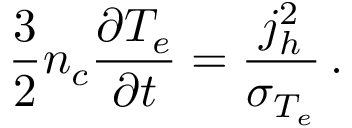<formula> <loc_0><loc_0><loc_500><loc_500>\frac { 3 } { 2 } n _ { c } \frac { \partial T _ { e } } { \partial t } = \frac { j _ { h } ^ { 2 } } { \sigma _ { T _ { e } } } \, .</formula> 